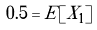<formula> <loc_0><loc_0><loc_500><loc_500>0 . 5 = E [ X _ { 1 } ]</formula> 